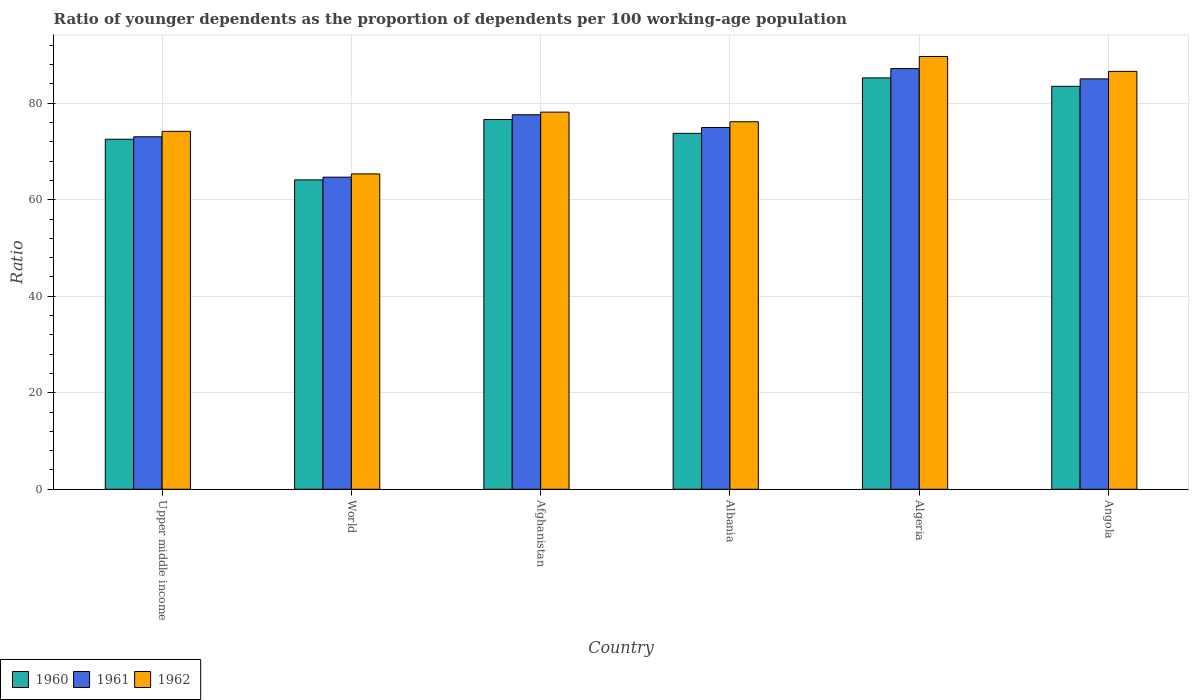How many different coloured bars are there?
Your answer should be very brief. 3. Are the number of bars per tick equal to the number of legend labels?
Keep it short and to the point. Yes. How many bars are there on the 2nd tick from the left?
Keep it short and to the point. 3. How many bars are there on the 1st tick from the right?
Provide a succinct answer. 3. What is the label of the 3rd group of bars from the left?
Your answer should be very brief. Afghanistan. What is the age dependency ratio(young) in 1962 in Algeria?
Keep it short and to the point. 89.69. Across all countries, what is the maximum age dependency ratio(young) in 1962?
Give a very brief answer. 89.69. Across all countries, what is the minimum age dependency ratio(young) in 1962?
Give a very brief answer. 65.36. In which country was the age dependency ratio(young) in 1960 maximum?
Provide a short and direct response. Algeria. In which country was the age dependency ratio(young) in 1961 minimum?
Make the answer very short. World. What is the total age dependency ratio(young) in 1960 in the graph?
Your response must be concise. 455.84. What is the difference between the age dependency ratio(young) in 1961 in Afghanistan and that in World?
Keep it short and to the point. 12.94. What is the difference between the age dependency ratio(young) in 1962 in Algeria and the age dependency ratio(young) in 1960 in Afghanistan?
Provide a succinct answer. 13.06. What is the average age dependency ratio(young) in 1962 per country?
Ensure brevity in your answer.  78.36. What is the difference between the age dependency ratio(young) of/in 1960 and age dependency ratio(young) of/in 1961 in Albania?
Your response must be concise. -1.21. In how many countries, is the age dependency ratio(young) in 1960 greater than 12?
Keep it short and to the point. 6. What is the ratio of the age dependency ratio(young) in 1960 in Albania to that in Angola?
Ensure brevity in your answer.  0.88. What is the difference between the highest and the second highest age dependency ratio(young) in 1961?
Ensure brevity in your answer.  -7.43. What is the difference between the highest and the lowest age dependency ratio(young) in 1962?
Your answer should be very brief. 24.33. What does the 3rd bar from the left in World represents?
Make the answer very short. 1962. What does the 2nd bar from the right in Angola represents?
Ensure brevity in your answer.  1961. Is it the case that in every country, the sum of the age dependency ratio(young) in 1960 and age dependency ratio(young) in 1962 is greater than the age dependency ratio(young) in 1961?
Ensure brevity in your answer.  Yes. How many bars are there?
Provide a short and direct response. 18. Are all the bars in the graph horizontal?
Your answer should be compact. No. How many countries are there in the graph?
Your answer should be compact. 6. What is the difference between two consecutive major ticks on the Y-axis?
Your response must be concise. 20. Does the graph contain grids?
Provide a succinct answer. Yes. What is the title of the graph?
Your response must be concise. Ratio of younger dependents as the proportion of dependents per 100 working-age population. What is the label or title of the Y-axis?
Give a very brief answer. Ratio. What is the Ratio in 1960 in Upper middle income?
Ensure brevity in your answer.  72.54. What is the Ratio in 1961 in Upper middle income?
Keep it short and to the point. 73.05. What is the Ratio of 1962 in Upper middle income?
Offer a very short reply. 74.18. What is the Ratio of 1960 in World?
Ensure brevity in your answer.  64.12. What is the Ratio in 1961 in World?
Make the answer very short. 64.68. What is the Ratio of 1962 in World?
Make the answer very short. 65.36. What is the Ratio of 1960 in Afghanistan?
Provide a short and direct response. 76.63. What is the Ratio of 1961 in Afghanistan?
Offer a very short reply. 77.62. What is the Ratio of 1962 in Afghanistan?
Keep it short and to the point. 78.17. What is the Ratio of 1960 in Albania?
Keep it short and to the point. 73.77. What is the Ratio in 1961 in Albania?
Provide a succinct answer. 74.98. What is the Ratio of 1962 in Albania?
Your response must be concise. 76.17. What is the Ratio in 1960 in Algeria?
Offer a terse response. 85.26. What is the Ratio of 1961 in Algeria?
Make the answer very short. 87.19. What is the Ratio in 1962 in Algeria?
Provide a succinct answer. 89.69. What is the Ratio in 1960 in Angola?
Your response must be concise. 83.52. What is the Ratio of 1961 in Angola?
Give a very brief answer. 85.05. What is the Ratio of 1962 in Angola?
Give a very brief answer. 86.61. Across all countries, what is the maximum Ratio in 1960?
Your response must be concise. 85.26. Across all countries, what is the maximum Ratio of 1961?
Give a very brief answer. 87.19. Across all countries, what is the maximum Ratio of 1962?
Keep it short and to the point. 89.69. Across all countries, what is the minimum Ratio in 1960?
Provide a short and direct response. 64.12. Across all countries, what is the minimum Ratio in 1961?
Provide a short and direct response. 64.68. Across all countries, what is the minimum Ratio in 1962?
Your response must be concise. 65.36. What is the total Ratio of 1960 in the graph?
Offer a terse response. 455.84. What is the total Ratio in 1961 in the graph?
Ensure brevity in your answer.  462.59. What is the total Ratio of 1962 in the graph?
Your response must be concise. 470.18. What is the difference between the Ratio of 1960 in Upper middle income and that in World?
Offer a very short reply. 8.42. What is the difference between the Ratio of 1961 in Upper middle income and that in World?
Your answer should be very brief. 8.37. What is the difference between the Ratio of 1962 in Upper middle income and that in World?
Provide a short and direct response. 8.82. What is the difference between the Ratio in 1960 in Upper middle income and that in Afghanistan?
Provide a short and direct response. -4.09. What is the difference between the Ratio in 1961 in Upper middle income and that in Afghanistan?
Keep it short and to the point. -4.57. What is the difference between the Ratio of 1962 in Upper middle income and that in Afghanistan?
Provide a short and direct response. -3.98. What is the difference between the Ratio of 1960 in Upper middle income and that in Albania?
Keep it short and to the point. -1.22. What is the difference between the Ratio in 1961 in Upper middle income and that in Albania?
Offer a very short reply. -1.93. What is the difference between the Ratio in 1962 in Upper middle income and that in Albania?
Provide a succinct answer. -1.99. What is the difference between the Ratio in 1960 in Upper middle income and that in Algeria?
Ensure brevity in your answer.  -12.71. What is the difference between the Ratio of 1961 in Upper middle income and that in Algeria?
Your response must be concise. -14.14. What is the difference between the Ratio in 1962 in Upper middle income and that in Algeria?
Make the answer very short. -15.51. What is the difference between the Ratio of 1960 in Upper middle income and that in Angola?
Keep it short and to the point. -10.97. What is the difference between the Ratio in 1961 in Upper middle income and that in Angola?
Your response must be concise. -12. What is the difference between the Ratio in 1962 in Upper middle income and that in Angola?
Provide a short and direct response. -12.43. What is the difference between the Ratio of 1960 in World and that in Afghanistan?
Offer a terse response. -12.51. What is the difference between the Ratio in 1961 in World and that in Afghanistan?
Your response must be concise. -12.94. What is the difference between the Ratio in 1962 in World and that in Afghanistan?
Provide a short and direct response. -12.81. What is the difference between the Ratio in 1960 in World and that in Albania?
Your answer should be very brief. -9.65. What is the difference between the Ratio in 1961 in World and that in Albania?
Offer a terse response. -10.3. What is the difference between the Ratio of 1962 in World and that in Albania?
Offer a very short reply. -10.81. What is the difference between the Ratio of 1960 in World and that in Algeria?
Ensure brevity in your answer.  -21.14. What is the difference between the Ratio in 1961 in World and that in Algeria?
Ensure brevity in your answer.  -22.51. What is the difference between the Ratio of 1962 in World and that in Algeria?
Keep it short and to the point. -24.33. What is the difference between the Ratio in 1960 in World and that in Angola?
Provide a short and direct response. -19.4. What is the difference between the Ratio of 1961 in World and that in Angola?
Provide a short and direct response. -20.37. What is the difference between the Ratio in 1962 in World and that in Angola?
Your answer should be very brief. -21.25. What is the difference between the Ratio of 1960 in Afghanistan and that in Albania?
Your answer should be compact. 2.86. What is the difference between the Ratio in 1961 in Afghanistan and that in Albania?
Offer a terse response. 2.64. What is the difference between the Ratio of 1962 in Afghanistan and that in Albania?
Your answer should be very brief. 1.99. What is the difference between the Ratio of 1960 in Afghanistan and that in Algeria?
Offer a terse response. -8.63. What is the difference between the Ratio in 1961 in Afghanistan and that in Algeria?
Your answer should be compact. -9.57. What is the difference between the Ratio in 1962 in Afghanistan and that in Algeria?
Provide a succinct answer. -11.53. What is the difference between the Ratio in 1960 in Afghanistan and that in Angola?
Keep it short and to the point. -6.88. What is the difference between the Ratio in 1961 in Afghanistan and that in Angola?
Keep it short and to the point. -7.43. What is the difference between the Ratio in 1962 in Afghanistan and that in Angola?
Provide a succinct answer. -8.44. What is the difference between the Ratio in 1960 in Albania and that in Algeria?
Your response must be concise. -11.49. What is the difference between the Ratio in 1961 in Albania and that in Algeria?
Your answer should be very brief. -12.21. What is the difference between the Ratio in 1962 in Albania and that in Algeria?
Make the answer very short. -13.52. What is the difference between the Ratio in 1960 in Albania and that in Angola?
Offer a terse response. -9.75. What is the difference between the Ratio of 1961 in Albania and that in Angola?
Offer a terse response. -10.07. What is the difference between the Ratio of 1962 in Albania and that in Angola?
Offer a terse response. -10.44. What is the difference between the Ratio of 1960 in Algeria and that in Angola?
Keep it short and to the point. 1.74. What is the difference between the Ratio in 1961 in Algeria and that in Angola?
Offer a terse response. 2.14. What is the difference between the Ratio in 1962 in Algeria and that in Angola?
Keep it short and to the point. 3.08. What is the difference between the Ratio of 1960 in Upper middle income and the Ratio of 1961 in World?
Provide a succinct answer. 7.86. What is the difference between the Ratio of 1960 in Upper middle income and the Ratio of 1962 in World?
Offer a very short reply. 7.19. What is the difference between the Ratio in 1961 in Upper middle income and the Ratio in 1962 in World?
Ensure brevity in your answer.  7.7. What is the difference between the Ratio in 1960 in Upper middle income and the Ratio in 1961 in Afghanistan?
Offer a very short reply. -5.08. What is the difference between the Ratio of 1960 in Upper middle income and the Ratio of 1962 in Afghanistan?
Keep it short and to the point. -5.62. What is the difference between the Ratio in 1961 in Upper middle income and the Ratio in 1962 in Afghanistan?
Your response must be concise. -5.11. What is the difference between the Ratio in 1960 in Upper middle income and the Ratio in 1961 in Albania?
Your answer should be very brief. -2.44. What is the difference between the Ratio of 1960 in Upper middle income and the Ratio of 1962 in Albania?
Ensure brevity in your answer.  -3.63. What is the difference between the Ratio in 1961 in Upper middle income and the Ratio in 1962 in Albania?
Ensure brevity in your answer.  -3.12. What is the difference between the Ratio of 1960 in Upper middle income and the Ratio of 1961 in Algeria?
Keep it short and to the point. -14.65. What is the difference between the Ratio of 1960 in Upper middle income and the Ratio of 1962 in Algeria?
Provide a short and direct response. -17.15. What is the difference between the Ratio in 1961 in Upper middle income and the Ratio in 1962 in Algeria?
Make the answer very short. -16.64. What is the difference between the Ratio of 1960 in Upper middle income and the Ratio of 1961 in Angola?
Ensure brevity in your answer.  -12.51. What is the difference between the Ratio in 1960 in Upper middle income and the Ratio in 1962 in Angola?
Provide a short and direct response. -14.06. What is the difference between the Ratio in 1961 in Upper middle income and the Ratio in 1962 in Angola?
Your answer should be very brief. -13.55. What is the difference between the Ratio in 1960 in World and the Ratio in 1961 in Afghanistan?
Give a very brief answer. -13.5. What is the difference between the Ratio in 1960 in World and the Ratio in 1962 in Afghanistan?
Offer a very short reply. -14.04. What is the difference between the Ratio of 1961 in World and the Ratio of 1962 in Afghanistan?
Provide a succinct answer. -13.48. What is the difference between the Ratio of 1960 in World and the Ratio of 1961 in Albania?
Your answer should be compact. -10.86. What is the difference between the Ratio of 1960 in World and the Ratio of 1962 in Albania?
Your answer should be very brief. -12.05. What is the difference between the Ratio in 1961 in World and the Ratio in 1962 in Albania?
Provide a succinct answer. -11.49. What is the difference between the Ratio of 1960 in World and the Ratio of 1961 in Algeria?
Offer a very short reply. -23.07. What is the difference between the Ratio in 1960 in World and the Ratio in 1962 in Algeria?
Ensure brevity in your answer.  -25.57. What is the difference between the Ratio in 1961 in World and the Ratio in 1962 in Algeria?
Provide a succinct answer. -25.01. What is the difference between the Ratio of 1960 in World and the Ratio of 1961 in Angola?
Your answer should be very brief. -20.93. What is the difference between the Ratio in 1960 in World and the Ratio in 1962 in Angola?
Your response must be concise. -22.49. What is the difference between the Ratio in 1961 in World and the Ratio in 1962 in Angola?
Your response must be concise. -21.93. What is the difference between the Ratio of 1960 in Afghanistan and the Ratio of 1961 in Albania?
Keep it short and to the point. 1.65. What is the difference between the Ratio of 1960 in Afghanistan and the Ratio of 1962 in Albania?
Keep it short and to the point. 0.46. What is the difference between the Ratio in 1961 in Afghanistan and the Ratio in 1962 in Albania?
Your answer should be compact. 1.45. What is the difference between the Ratio in 1960 in Afghanistan and the Ratio in 1961 in Algeria?
Give a very brief answer. -10.56. What is the difference between the Ratio of 1960 in Afghanistan and the Ratio of 1962 in Algeria?
Your answer should be very brief. -13.06. What is the difference between the Ratio in 1961 in Afghanistan and the Ratio in 1962 in Algeria?
Your response must be concise. -12.07. What is the difference between the Ratio of 1960 in Afghanistan and the Ratio of 1961 in Angola?
Your answer should be very brief. -8.42. What is the difference between the Ratio of 1960 in Afghanistan and the Ratio of 1962 in Angola?
Your answer should be very brief. -9.98. What is the difference between the Ratio in 1961 in Afghanistan and the Ratio in 1962 in Angola?
Offer a terse response. -8.99. What is the difference between the Ratio in 1960 in Albania and the Ratio in 1961 in Algeria?
Your response must be concise. -13.42. What is the difference between the Ratio of 1960 in Albania and the Ratio of 1962 in Algeria?
Offer a very short reply. -15.92. What is the difference between the Ratio in 1961 in Albania and the Ratio in 1962 in Algeria?
Keep it short and to the point. -14.71. What is the difference between the Ratio of 1960 in Albania and the Ratio of 1961 in Angola?
Make the answer very short. -11.29. What is the difference between the Ratio in 1960 in Albania and the Ratio in 1962 in Angola?
Your response must be concise. -12.84. What is the difference between the Ratio in 1961 in Albania and the Ratio in 1962 in Angola?
Ensure brevity in your answer.  -11.63. What is the difference between the Ratio of 1960 in Algeria and the Ratio of 1961 in Angola?
Offer a terse response. 0.2. What is the difference between the Ratio of 1960 in Algeria and the Ratio of 1962 in Angola?
Provide a succinct answer. -1.35. What is the difference between the Ratio in 1961 in Algeria and the Ratio in 1962 in Angola?
Your response must be concise. 0.58. What is the average Ratio of 1960 per country?
Provide a succinct answer. 75.97. What is the average Ratio in 1961 per country?
Offer a terse response. 77.1. What is the average Ratio in 1962 per country?
Your answer should be compact. 78.36. What is the difference between the Ratio of 1960 and Ratio of 1961 in Upper middle income?
Provide a short and direct response. -0.51. What is the difference between the Ratio in 1960 and Ratio in 1962 in Upper middle income?
Your answer should be compact. -1.64. What is the difference between the Ratio of 1961 and Ratio of 1962 in Upper middle income?
Make the answer very short. -1.13. What is the difference between the Ratio in 1960 and Ratio in 1961 in World?
Offer a very short reply. -0.56. What is the difference between the Ratio in 1960 and Ratio in 1962 in World?
Your answer should be very brief. -1.24. What is the difference between the Ratio of 1961 and Ratio of 1962 in World?
Provide a succinct answer. -0.67. What is the difference between the Ratio of 1960 and Ratio of 1961 in Afghanistan?
Offer a very short reply. -0.99. What is the difference between the Ratio of 1960 and Ratio of 1962 in Afghanistan?
Your answer should be very brief. -1.53. What is the difference between the Ratio of 1961 and Ratio of 1962 in Afghanistan?
Your response must be concise. -0.54. What is the difference between the Ratio in 1960 and Ratio in 1961 in Albania?
Offer a terse response. -1.21. What is the difference between the Ratio of 1960 and Ratio of 1962 in Albania?
Your answer should be compact. -2.4. What is the difference between the Ratio in 1961 and Ratio in 1962 in Albania?
Offer a very short reply. -1.19. What is the difference between the Ratio of 1960 and Ratio of 1961 in Algeria?
Your answer should be very brief. -1.93. What is the difference between the Ratio of 1960 and Ratio of 1962 in Algeria?
Provide a succinct answer. -4.43. What is the difference between the Ratio in 1961 and Ratio in 1962 in Algeria?
Keep it short and to the point. -2.5. What is the difference between the Ratio of 1960 and Ratio of 1961 in Angola?
Your response must be concise. -1.54. What is the difference between the Ratio of 1960 and Ratio of 1962 in Angola?
Offer a terse response. -3.09. What is the difference between the Ratio of 1961 and Ratio of 1962 in Angola?
Keep it short and to the point. -1.55. What is the ratio of the Ratio of 1960 in Upper middle income to that in World?
Give a very brief answer. 1.13. What is the ratio of the Ratio of 1961 in Upper middle income to that in World?
Offer a terse response. 1.13. What is the ratio of the Ratio of 1962 in Upper middle income to that in World?
Your answer should be very brief. 1.14. What is the ratio of the Ratio of 1960 in Upper middle income to that in Afghanistan?
Keep it short and to the point. 0.95. What is the ratio of the Ratio in 1961 in Upper middle income to that in Afghanistan?
Give a very brief answer. 0.94. What is the ratio of the Ratio in 1962 in Upper middle income to that in Afghanistan?
Make the answer very short. 0.95. What is the ratio of the Ratio in 1960 in Upper middle income to that in Albania?
Keep it short and to the point. 0.98. What is the ratio of the Ratio in 1961 in Upper middle income to that in Albania?
Provide a succinct answer. 0.97. What is the ratio of the Ratio in 1962 in Upper middle income to that in Albania?
Offer a terse response. 0.97. What is the ratio of the Ratio in 1960 in Upper middle income to that in Algeria?
Your answer should be very brief. 0.85. What is the ratio of the Ratio of 1961 in Upper middle income to that in Algeria?
Offer a very short reply. 0.84. What is the ratio of the Ratio of 1962 in Upper middle income to that in Algeria?
Ensure brevity in your answer.  0.83. What is the ratio of the Ratio of 1960 in Upper middle income to that in Angola?
Give a very brief answer. 0.87. What is the ratio of the Ratio in 1961 in Upper middle income to that in Angola?
Give a very brief answer. 0.86. What is the ratio of the Ratio of 1962 in Upper middle income to that in Angola?
Provide a succinct answer. 0.86. What is the ratio of the Ratio in 1960 in World to that in Afghanistan?
Your response must be concise. 0.84. What is the ratio of the Ratio of 1961 in World to that in Afghanistan?
Offer a very short reply. 0.83. What is the ratio of the Ratio in 1962 in World to that in Afghanistan?
Your answer should be very brief. 0.84. What is the ratio of the Ratio in 1960 in World to that in Albania?
Give a very brief answer. 0.87. What is the ratio of the Ratio in 1961 in World to that in Albania?
Make the answer very short. 0.86. What is the ratio of the Ratio of 1962 in World to that in Albania?
Provide a short and direct response. 0.86. What is the ratio of the Ratio in 1960 in World to that in Algeria?
Offer a very short reply. 0.75. What is the ratio of the Ratio in 1961 in World to that in Algeria?
Provide a short and direct response. 0.74. What is the ratio of the Ratio of 1962 in World to that in Algeria?
Make the answer very short. 0.73. What is the ratio of the Ratio in 1960 in World to that in Angola?
Provide a short and direct response. 0.77. What is the ratio of the Ratio of 1961 in World to that in Angola?
Make the answer very short. 0.76. What is the ratio of the Ratio in 1962 in World to that in Angola?
Offer a very short reply. 0.75. What is the ratio of the Ratio in 1960 in Afghanistan to that in Albania?
Make the answer very short. 1.04. What is the ratio of the Ratio in 1961 in Afghanistan to that in Albania?
Offer a terse response. 1.04. What is the ratio of the Ratio in 1962 in Afghanistan to that in Albania?
Make the answer very short. 1.03. What is the ratio of the Ratio of 1960 in Afghanistan to that in Algeria?
Offer a very short reply. 0.9. What is the ratio of the Ratio of 1961 in Afghanistan to that in Algeria?
Ensure brevity in your answer.  0.89. What is the ratio of the Ratio in 1962 in Afghanistan to that in Algeria?
Offer a terse response. 0.87. What is the ratio of the Ratio in 1960 in Afghanistan to that in Angola?
Give a very brief answer. 0.92. What is the ratio of the Ratio in 1961 in Afghanistan to that in Angola?
Your answer should be very brief. 0.91. What is the ratio of the Ratio in 1962 in Afghanistan to that in Angola?
Your answer should be compact. 0.9. What is the ratio of the Ratio in 1960 in Albania to that in Algeria?
Provide a succinct answer. 0.87. What is the ratio of the Ratio in 1961 in Albania to that in Algeria?
Your response must be concise. 0.86. What is the ratio of the Ratio in 1962 in Albania to that in Algeria?
Offer a terse response. 0.85. What is the ratio of the Ratio of 1960 in Albania to that in Angola?
Keep it short and to the point. 0.88. What is the ratio of the Ratio in 1961 in Albania to that in Angola?
Provide a short and direct response. 0.88. What is the ratio of the Ratio in 1962 in Albania to that in Angola?
Give a very brief answer. 0.88. What is the ratio of the Ratio of 1960 in Algeria to that in Angola?
Keep it short and to the point. 1.02. What is the ratio of the Ratio of 1961 in Algeria to that in Angola?
Your response must be concise. 1.03. What is the ratio of the Ratio in 1962 in Algeria to that in Angola?
Make the answer very short. 1.04. What is the difference between the highest and the second highest Ratio of 1960?
Your response must be concise. 1.74. What is the difference between the highest and the second highest Ratio of 1961?
Make the answer very short. 2.14. What is the difference between the highest and the second highest Ratio in 1962?
Your answer should be compact. 3.08. What is the difference between the highest and the lowest Ratio of 1960?
Keep it short and to the point. 21.14. What is the difference between the highest and the lowest Ratio in 1961?
Your answer should be compact. 22.51. What is the difference between the highest and the lowest Ratio in 1962?
Make the answer very short. 24.33. 